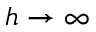<formula> <loc_0><loc_0><loc_500><loc_500>h \rightarrow \infty</formula> 